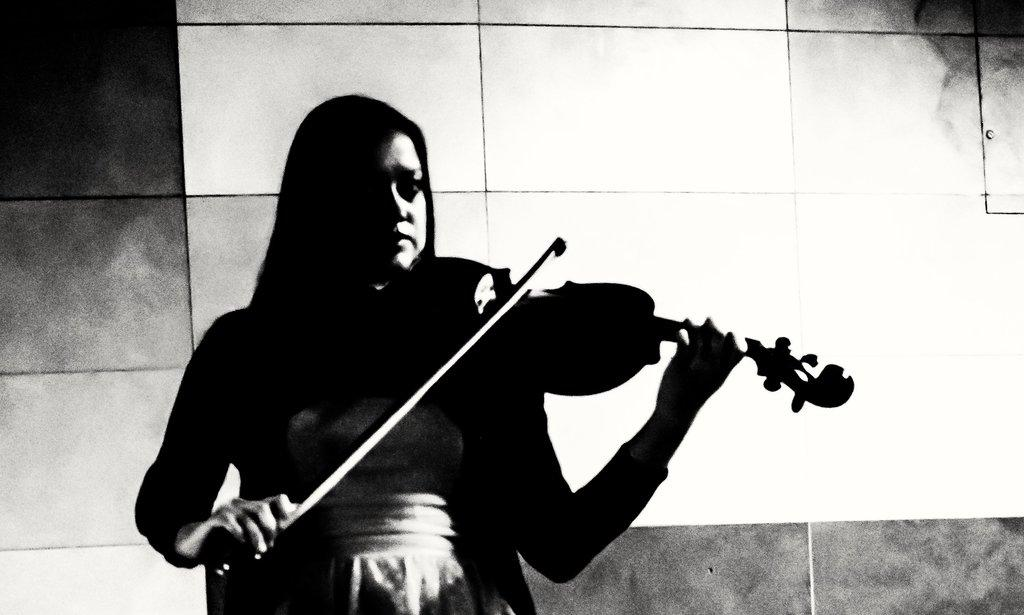Who is the main subject in the image? There is a woman in the image. What is the woman doing in the image? The woman is standing and playing a violin. What can be seen in the background of the image? There is a wall in the background of the image. What type of coil is the woman using to play the violin in the image? There is no coil present in the image; the woman is playing a violin using a bow. Can you tell me how many requests the woman is making in the image? There is no indication of any requests being made in the image; the woman is simply playing a violin. 